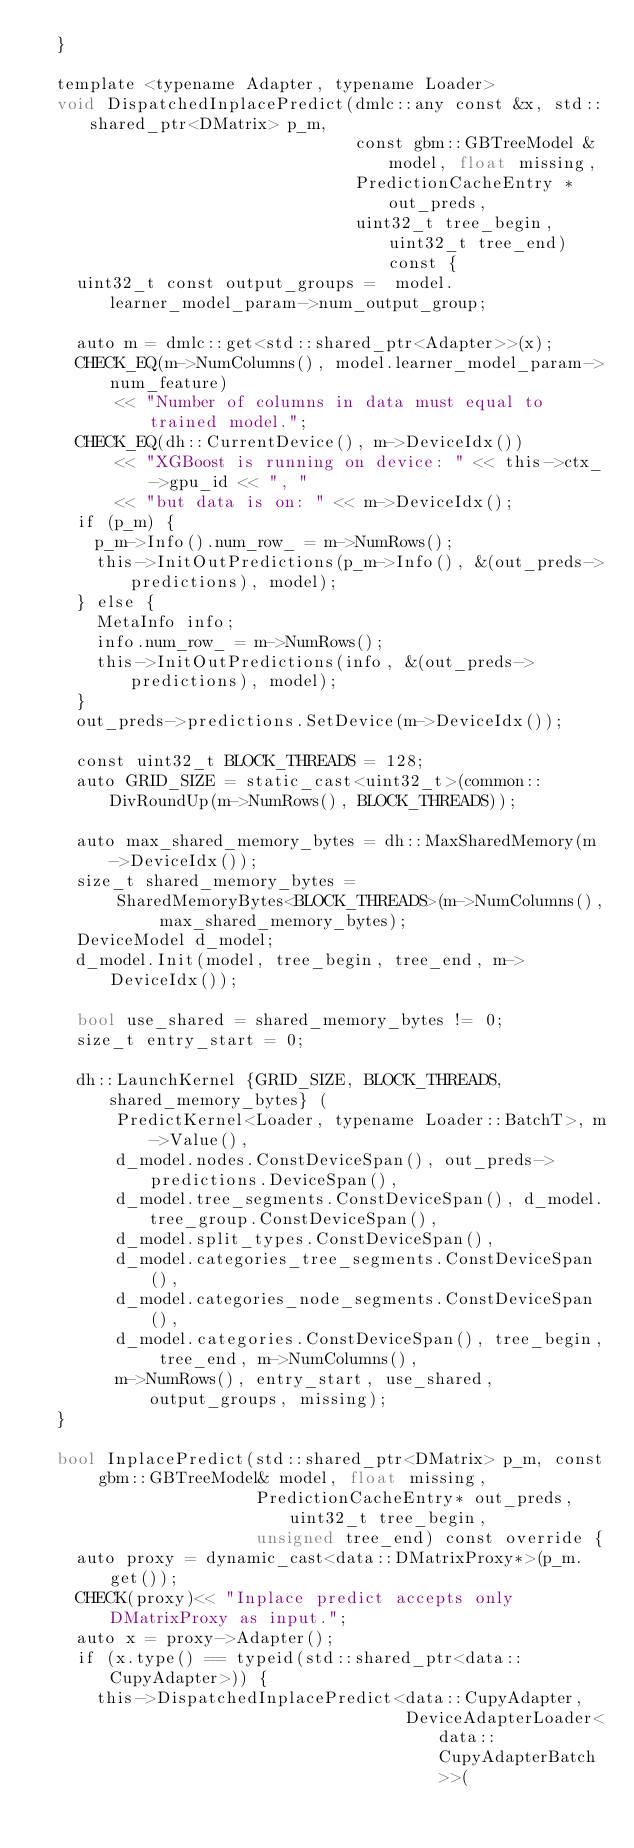Convert code to text. <code><loc_0><loc_0><loc_500><loc_500><_Cuda_>  }

  template <typename Adapter, typename Loader>
  void DispatchedInplacePredict(dmlc::any const &x, std::shared_ptr<DMatrix> p_m,
                                const gbm::GBTreeModel &model, float missing,
                                PredictionCacheEntry *out_preds,
                                uint32_t tree_begin, uint32_t tree_end) const {
    uint32_t const output_groups =  model.learner_model_param->num_output_group;

    auto m = dmlc::get<std::shared_ptr<Adapter>>(x);
    CHECK_EQ(m->NumColumns(), model.learner_model_param->num_feature)
        << "Number of columns in data must equal to trained model.";
    CHECK_EQ(dh::CurrentDevice(), m->DeviceIdx())
        << "XGBoost is running on device: " << this->ctx_->gpu_id << ", "
        << "but data is on: " << m->DeviceIdx();
    if (p_m) {
      p_m->Info().num_row_ = m->NumRows();
      this->InitOutPredictions(p_m->Info(), &(out_preds->predictions), model);
    } else {
      MetaInfo info;
      info.num_row_ = m->NumRows();
      this->InitOutPredictions(info, &(out_preds->predictions), model);
    }
    out_preds->predictions.SetDevice(m->DeviceIdx());

    const uint32_t BLOCK_THREADS = 128;
    auto GRID_SIZE = static_cast<uint32_t>(common::DivRoundUp(m->NumRows(), BLOCK_THREADS));

    auto max_shared_memory_bytes = dh::MaxSharedMemory(m->DeviceIdx());
    size_t shared_memory_bytes =
        SharedMemoryBytes<BLOCK_THREADS>(m->NumColumns(), max_shared_memory_bytes);
    DeviceModel d_model;
    d_model.Init(model, tree_begin, tree_end, m->DeviceIdx());

    bool use_shared = shared_memory_bytes != 0;
    size_t entry_start = 0;

    dh::LaunchKernel {GRID_SIZE, BLOCK_THREADS, shared_memory_bytes} (
        PredictKernel<Loader, typename Loader::BatchT>, m->Value(),
        d_model.nodes.ConstDeviceSpan(), out_preds->predictions.DeviceSpan(),
        d_model.tree_segments.ConstDeviceSpan(), d_model.tree_group.ConstDeviceSpan(),
        d_model.split_types.ConstDeviceSpan(),
        d_model.categories_tree_segments.ConstDeviceSpan(),
        d_model.categories_node_segments.ConstDeviceSpan(),
        d_model.categories.ConstDeviceSpan(), tree_begin, tree_end, m->NumColumns(),
        m->NumRows(), entry_start, use_shared, output_groups, missing);
  }

  bool InplacePredict(std::shared_ptr<DMatrix> p_m, const gbm::GBTreeModel& model, float missing,
                      PredictionCacheEntry* out_preds, uint32_t tree_begin,
                      unsigned tree_end) const override {
    auto proxy = dynamic_cast<data::DMatrixProxy*>(p_m.get());
    CHECK(proxy)<< "Inplace predict accepts only DMatrixProxy as input.";
    auto x = proxy->Adapter();
    if (x.type() == typeid(std::shared_ptr<data::CupyAdapter>)) {
      this->DispatchedInplacePredict<data::CupyAdapter,
                                     DeviceAdapterLoader<data::CupyAdapterBatch>>(</code> 